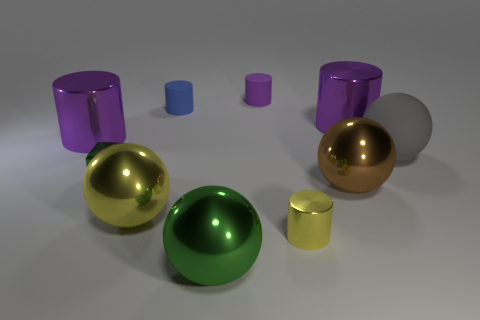The sphere that is the same color as the tiny metallic cylinder is what size?
Offer a terse response. Large. There is a green ball that is the same material as the green block; what is its size?
Provide a succinct answer. Large. What shape is the large yellow object that is the same material as the big brown ball?
Keep it short and to the point. Sphere. What material is the block?
Provide a succinct answer. Metal. The metal block is what color?
Keep it short and to the point. Green. There is a big object that is in front of the large matte thing and to the left of the blue matte cylinder; what is its color?
Your response must be concise. Yellow. Is there any other thing that is made of the same material as the big gray object?
Your answer should be compact. Yes. Is the big green object made of the same material as the purple thing on the right side of the yellow cylinder?
Ensure brevity in your answer.  Yes. How big is the purple cylinder that is to the right of the yellow object that is to the right of the large green sphere?
Offer a terse response. Large. Is there anything else that has the same color as the matte ball?
Your response must be concise. No. 